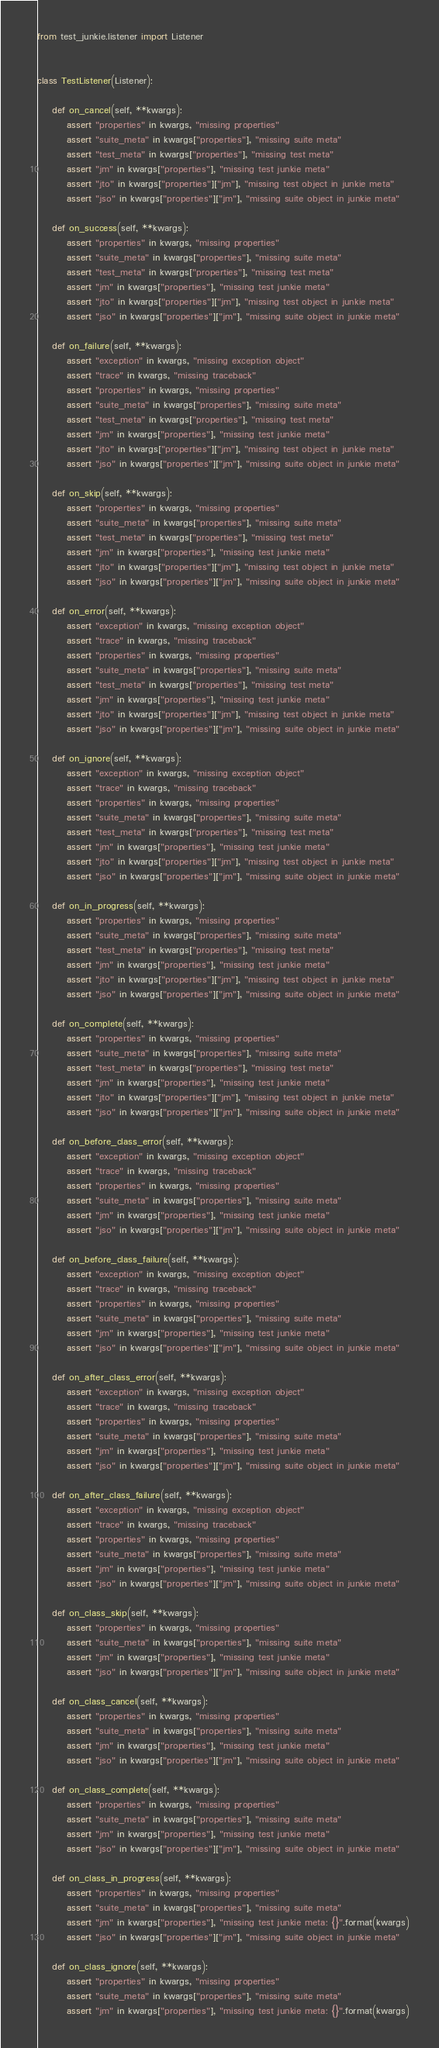<code> <loc_0><loc_0><loc_500><loc_500><_Python_>from test_junkie.listener import Listener


class TestListener(Listener):

    def on_cancel(self, **kwargs):
        assert "properties" in kwargs, "missing properties"
        assert "suite_meta" in kwargs["properties"], "missing suite meta"
        assert "test_meta" in kwargs["properties"], "missing test meta"
        assert "jm" in kwargs["properties"], "missing test junkie meta"
        assert "jto" in kwargs["properties"]["jm"], "missing test object in junkie meta"
        assert "jso" in kwargs["properties"]["jm"], "missing suite object in junkie meta"

    def on_success(self, **kwargs):
        assert "properties" in kwargs, "missing properties"
        assert "suite_meta" in kwargs["properties"], "missing suite meta"
        assert "test_meta" in kwargs["properties"], "missing test meta"
        assert "jm" in kwargs["properties"], "missing test junkie meta"
        assert "jto" in kwargs["properties"]["jm"], "missing test object in junkie meta"
        assert "jso" in kwargs["properties"]["jm"], "missing suite object in junkie meta"

    def on_failure(self, **kwargs):
        assert "exception" in kwargs, "missing exception object"
        assert "trace" in kwargs, "missing traceback"
        assert "properties" in kwargs, "missing properties"
        assert "suite_meta" in kwargs["properties"], "missing suite meta"
        assert "test_meta" in kwargs["properties"], "missing test meta"
        assert "jm" in kwargs["properties"], "missing test junkie meta"
        assert "jto" in kwargs["properties"]["jm"], "missing test object in junkie meta"
        assert "jso" in kwargs["properties"]["jm"], "missing suite object in junkie meta"

    def on_skip(self, **kwargs):
        assert "properties" in kwargs, "missing properties"
        assert "suite_meta" in kwargs["properties"], "missing suite meta"
        assert "test_meta" in kwargs["properties"], "missing test meta"
        assert "jm" in kwargs["properties"], "missing test junkie meta"
        assert "jto" in kwargs["properties"]["jm"], "missing test object in junkie meta"
        assert "jso" in kwargs["properties"]["jm"], "missing suite object in junkie meta"

    def on_error(self, **kwargs):
        assert "exception" in kwargs, "missing exception object"
        assert "trace" in kwargs, "missing traceback"
        assert "properties" in kwargs, "missing properties"
        assert "suite_meta" in kwargs["properties"], "missing suite meta"
        assert "test_meta" in kwargs["properties"], "missing test meta"
        assert "jm" in kwargs["properties"], "missing test junkie meta"
        assert "jto" in kwargs["properties"]["jm"], "missing test object in junkie meta"
        assert "jso" in kwargs["properties"]["jm"], "missing suite object in junkie meta"

    def on_ignore(self, **kwargs):
        assert "exception" in kwargs, "missing exception object"
        assert "trace" in kwargs, "missing traceback"
        assert "properties" in kwargs, "missing properties"
        assert "suite_meta" in kwargs["properties"], "missing suite meta"
        assert "test_meta" in kwargs["properties"], "missing test meta"
        assert "jm" in kwargs["properties"], "missing test junkie meta"
        assert "jto" in kwargs["properties"]["jm"], "missing test object in junkie meta"
        assert "jso" in kwargs["properties"]["jm"], "missing suite object in junkie meta"

    def on_in_progress(self, **kwargs):
        assert "properties" in kwargs, "missing properties"
        assert "suite_meta" in kwargs["properties"], "missing suite meta"
        assert "test_meta" in kwargs["properties"], "missing test meta"
        assert "jm" in kwargs["properties"], "missing test junkie meta"
        assert "jto" in kwargs["properties"]["jm"], "missing test object in junkie meta"
        assert "jso" in kwargs["properties"]["jm"], "missing suite object in junkie meta"

    def on_complete(self, **kwargs):
        assert "properties" in kwargs, "missing properties"
        assert "suite_meta" in kwargs["properties"], "missing suite meta"
        assert "test_meta" in kwargs["properties"], "missing test meta"
        assert "jm" in kwargs["properties"], "missing test junkie meta"
        assert "jto" in kwargs["properties"]["jm"], "missing test object in junkie meta"
        assert "jso" in kwargs["properties"]["jm"], "missing suite object in junkie meta"

    def on_before_class_error(self, **kwargs):
        assert "exception" in kwargs, "missing exception object"
        assert "trace" in kwargs, "missing traceback"
        assert "properties" in kwargs, "missing properties"
        assert "suite_meta" in kwargs["properties"], "missing suite meta"
        assert "jm" in kwargs["properties"], "missing test junkie meta"
        assert "jso" in kwargs["properties"]["jm"], "missing suite object in junkie meta"

    def on_before_class_failure(self, **kwargs):
        assert "exception" in kwargs, "missing exception object"
        assert "trace" in kwargs, "missing traceback"
        assert "properties" in kwargs, "missing properties"
        assert "suite_meta" in kwargs["properties"], "missing suite meta"
        assert "jm" in kwargs["properties"], "missing test junkie meta"
        assert "jso" in kwargs["properties"]["jm"], "missing suite object in junkie meta"

    def on_after_class_error(self, **kwargs):
        assert "exception" in kwargs, "missing exception object"
        assert "trace" in kwargs, "missing traceback"
        assert "properties" in kwargs, "missing properties"
        assert "suite_meta" in kwargs["properties"], "missing suite meta"
        assert "jm" in kwargs["properties"], "missing test junkie meta"
        assert "jso" in kwargs["properties"]["jm"], "missing suite object in junkie meta"

    def on_after_class_failure(self, **kwargs):
        assert "exception" in kwargs, "missing exception object"
        assert "trace" in kwargs, "missing traceback"
        assert "properties" in kwargs, "missing properties"
        assert "suite_meta" in kwargs["properties"], "missing suite meta"
        assert "jm" in kwargs["properties"], "missing test junkie meta"
        assert "jso" in kwargs["properties"]["jm"], "missing suite object in junkie meta"

    def on_class_skip(self, **kwargs):
        assert "properties" in kwargs, "missing properties"
        assert "suite_meta" in kwargs["properties"], "missing suite meta"
        assert "jm" in kwargs["properties"], "missing test junkie meta"
        assert "jso" in kwargs["properties"]["jm"], "missing suite object in junkie meta"

    def on_class_cancel(self, **kwargs):
        assert "properties" in kwargs, "missing properties"
        assert "suite_meta" in kwargs["properties"], "missing suite meta"
        assert "jm" in kwargs["properties"], "missing test junkie meta"
        assert "jso" in kwargs["properties"]["jm"], "missing suite object in junkie meta"

    def on_class_complete(self, **kwargs):
        assert "properties" in kwargs, "missing properties"
        assert "suite_meta" in kwargs["properties"], "missing suite meta"
        assert "jm" in kwargs["properties"], "missing test junkie meta"
        assert "jso" in kwargs["properties"]["jm"], "missing suite object in junkie meta"

    def on_class_in_progress(self, **kwargs):
        assert "properties" in kwargs, "missing properties"
        assert "suite_meta" in kwargs["properties"], "missing suite meta"
        assert "jm" in kwargs["properties"], "missing test junkie meta: {}".format(kwargs)
        assert "jso" in kwargs["properties"]["jm"], "missing suite object in junkie meta"

    def on_class_ignore(self, **kwargs):
        assert "properties" in kwargs, "missing properties"
        assert "suite_meta" in kwargs["properties"], "missing suite meta"
        assert "jm" in kwargs["properties"], "missing test junkie meta: {}".format(kwargs)</code> 